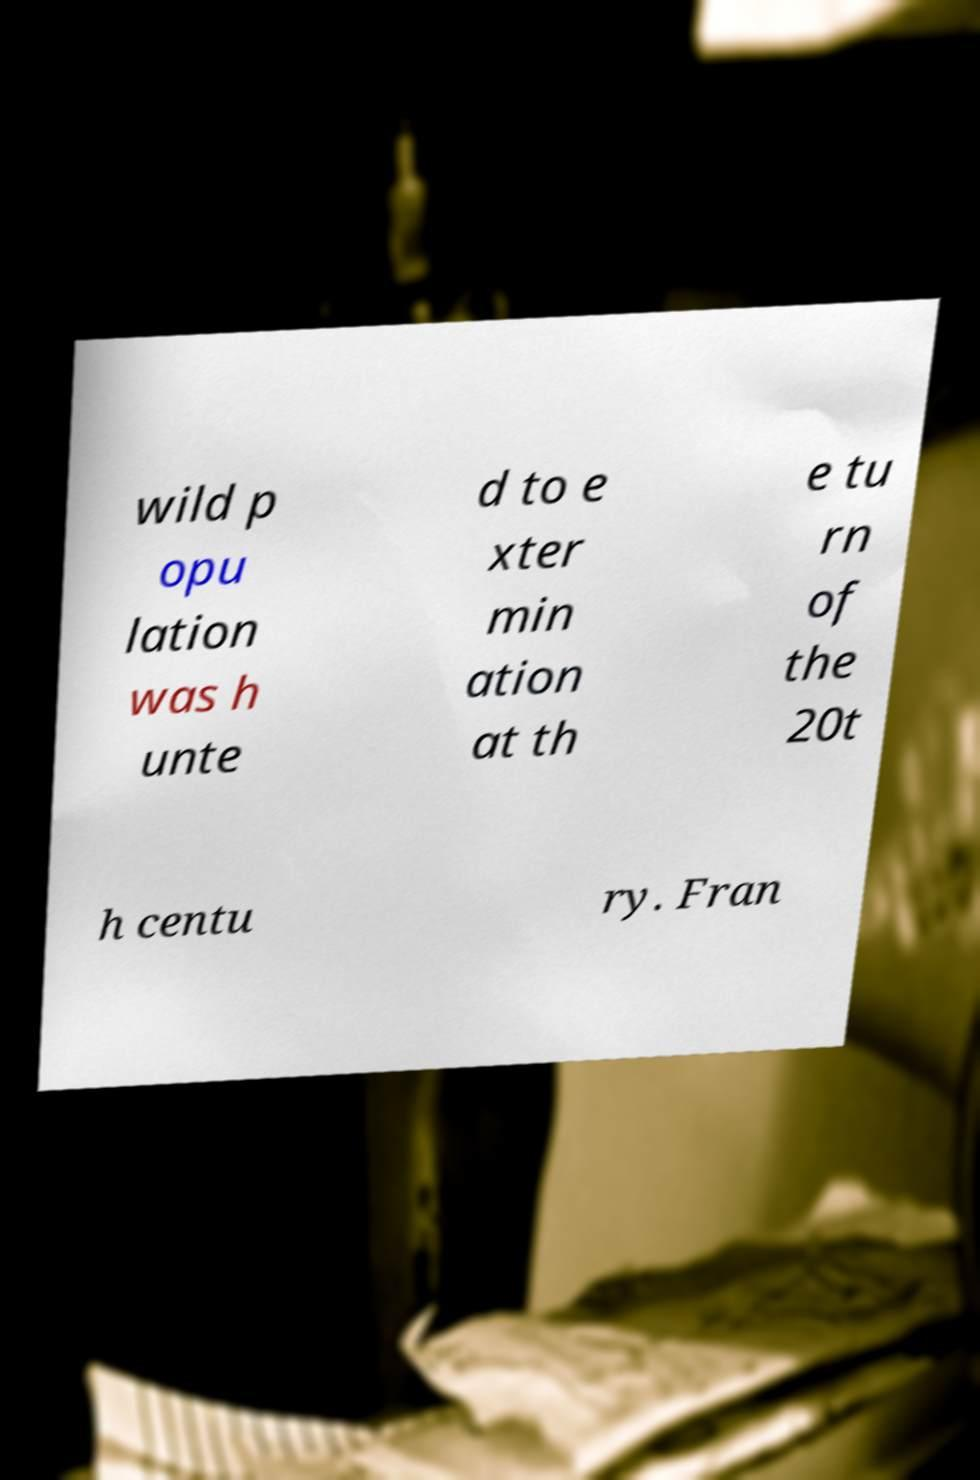Can you read and provide the text displayed in the image?This photo seems to have some interesting text. Can you extract and type it out for me? wild p opu lation was h unte d to e xter min ation at th e tu rn of the 20t h centu ry. Fran 